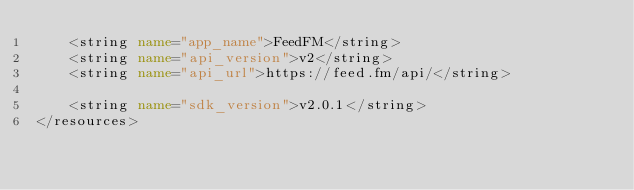Convert code to text. <code><loc_0><loc_0><loc_500><loc_500><_XML_>    <string name="app_name">FeedFM</string>
    <string name="api_version">v2</string>
    <string name="api_url">https://feed.fm/api/</string>

    <string name="sdk_version">v2.0.1</string>
</resources>
</code> 